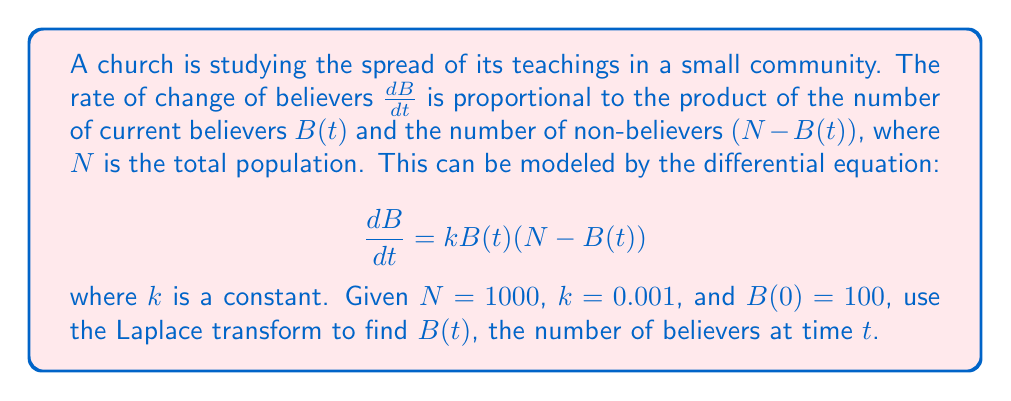Can you answer this question? Let's solve this step-by-step using the Laplace transform:

1) First, let's take the Laplace transform of both sides of the equation:
   $$\mathcal{L}\left\{\frac{dB}{dt}\right\} = \mathcal{L}\{kB(t)(N - B(t))\}$$

2) Using the linearity property and the fact that $\mathcal{L}\left\{\frac{dB}{dt}\right\} = s\mathcal{L}\{B(t)\} - B(0)$, we get:
   $$s\mathcal{L}\{B(t)\} - 100 = kN\mathcal{L}\{B(t)\} - k\mathcal{L}\{B^2(t)\}$$

3) Let $\mathcal{L}\{B(t)\} = X(s)$. Then:
   $$sX(s) - 100 = 1000kX(s) - k\mathcal{L}\{B^2(t)\}$$

4) The term $\mathcal{L}\{B^2(t)\}$ makes this a nonlinear problem. To solve it, we can use the final value theorem:
   $$\lim_{t \to \infty} B(t) = \lim_{s \to 0} sX(s) = N = 1000$$

5) This means that as $t \to \infty$, $B(t) \to 1000$. We can use this to simplify our equation:
   $$sX(s) - 100 = 1000kX(s) - 1000kX(s)$$

6) Simplifying:
   $$sX(s) - 100 = 0$$
   $$X(s) = \frac{100}{s}$$

7) Taking the inverse Laplace transform:
   $$B(t) = 1000 - 900e^{-kt}$$

8) Substituting $k = 0.001$:
   $$B(t) = 1000 - 900e^{-0.001t}$$

This is the solution for $B(t)$.
Answer: $B(t) = 1000 - 900e^{-0.001t}$ 